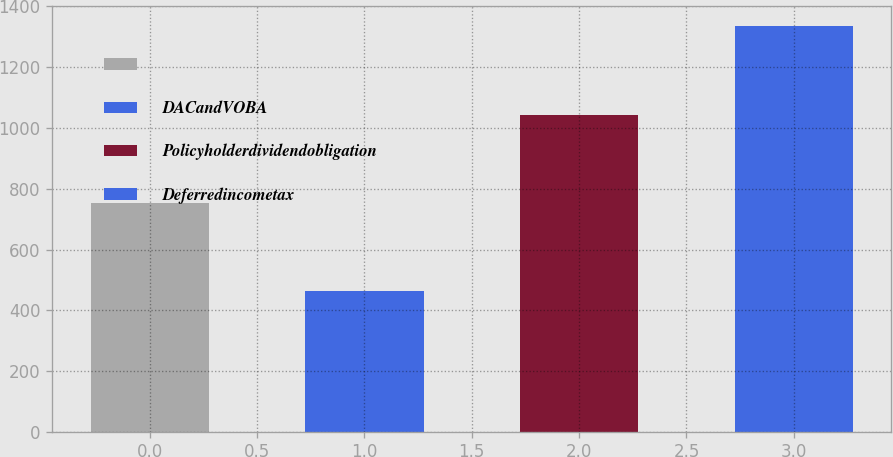Convert chart to OTSL. <chart><loc_0><loc_0><loc_500><loc_500><bar_chart><ecel><fcel>DACandVOBA<fcel>Policyholderdividendobligation<fcel>Deferredincometax<nl><fcel>753<fcel>462<fcel>1044<fcel>1335<nl></chart> 